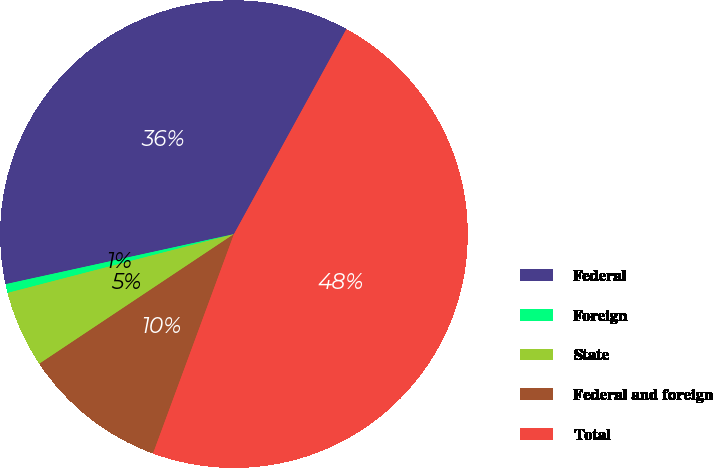Convert chart. <chart><loc_0><loc_0><loc_500><loc_500><pie_chart><fcel>Federal<fcel>Foreign<fcel>State<fcel>Federal and foreign<fcel>Total<nl><fcel>36.42%<fcel>0.61%<fcel>5.31%<fcel>10.02%<fcel>47.64%<nl></chart> 